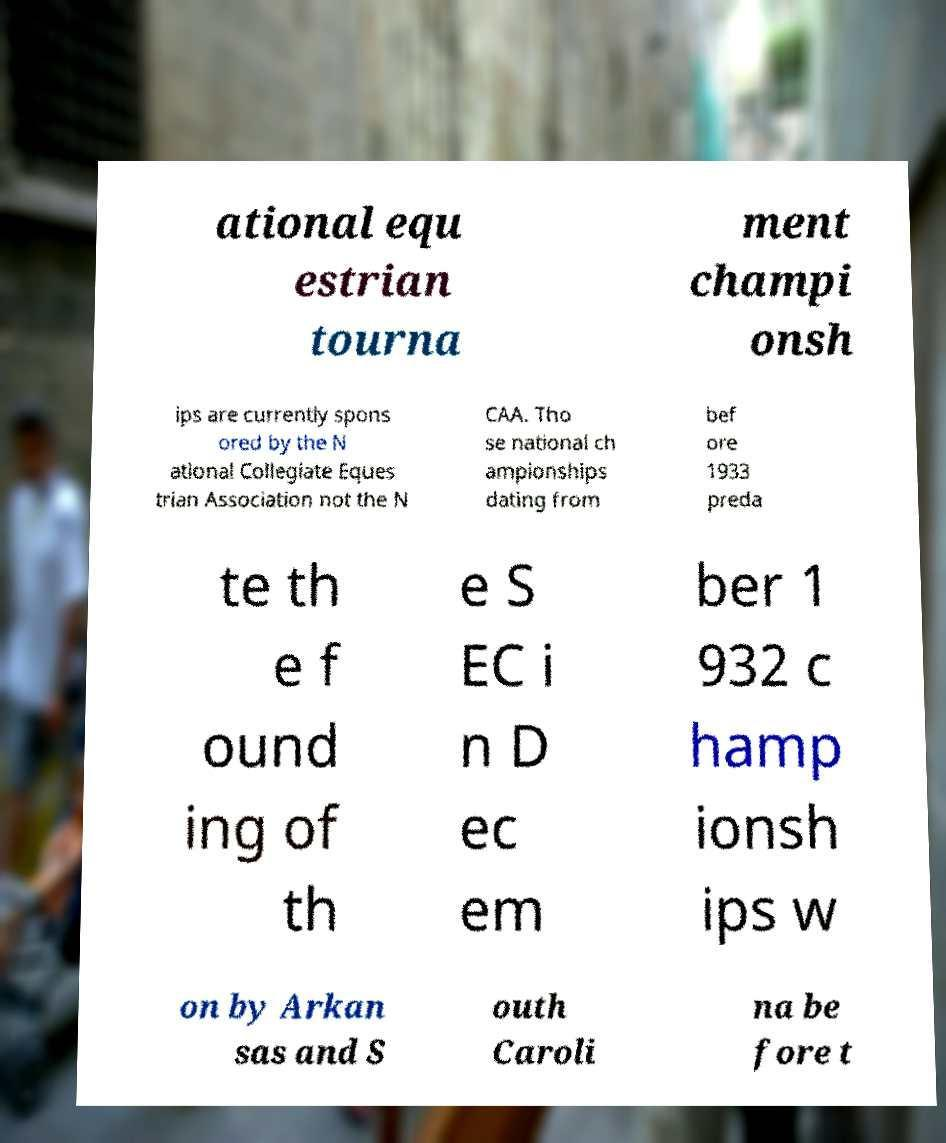What messages or text are displayed in this image? I need them in a readable, typed format. ational equ estrian tourna ment champi onsh ips are currently spons ored by the N ational Collegiate Eques trian Association not the N CAA. Tho se national ch ampionships dating from bef ore 1933 preda te th e f ound ing of th e S EC i n D ec em ber 1 932 c hamp ionsh ips w on by Arkan sas and S outh Caroli na be fore t 